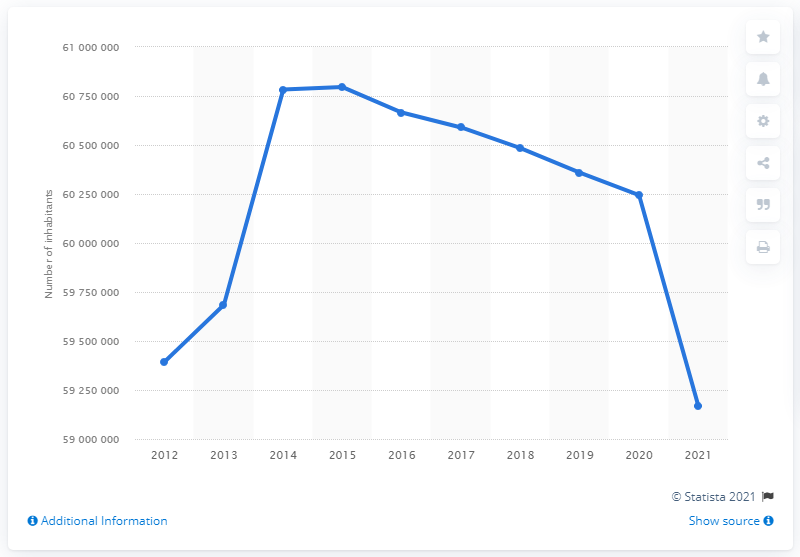List a handful of essential elements in this visual. Italy's population in 2021 was approximately 59,169,131. 